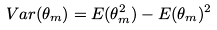Convert formula to latex. <formula><loc_0><loc_0><loc_500><loc_500>V a r ( \theta _ { m } ) = E ( \theta _ { m } ^ { 2 } ) - E ( \theta _ { m } ) ^ { 2 }</formula> 